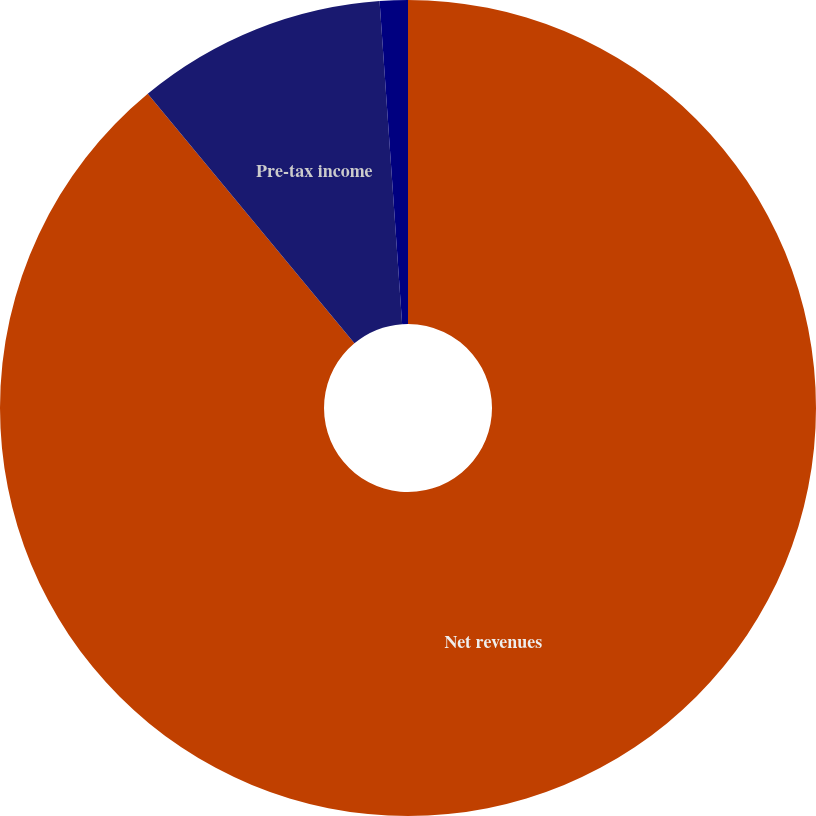<chart> <loc_0><loc_0><loc_500><loc_500><pie_chart><fcel>Net revenues<fcel>Pre-tax income<fcel>Pre-tax loss<nl><fcel>88.99%<fcel>9.9%<fcel>1.11%<nl></chart> 